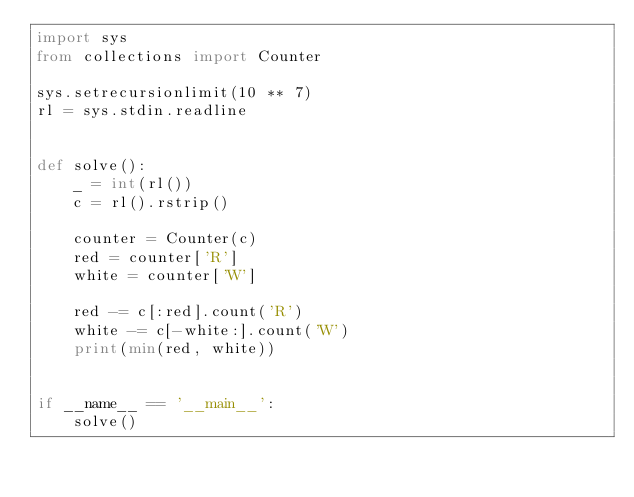Convert code to text. <code><loc_0><loc_0><loc_500><loc_500><_Python_>import sys
from collections import Counter

sys.setrecursionlimit(10 ** 7)
rl = sys.stdin.readline


def solve():
    _ = int(rl())
    c = rl().rstrip()
    
    counter = Counter(c)
    red = counter['R']
    white = counter['W']
    
    red -= c[:red].count('R')
    white -= c[-white:].count('W')
    print(min(red, white))


if __name__ == '__main__':
    solve()
</code> 